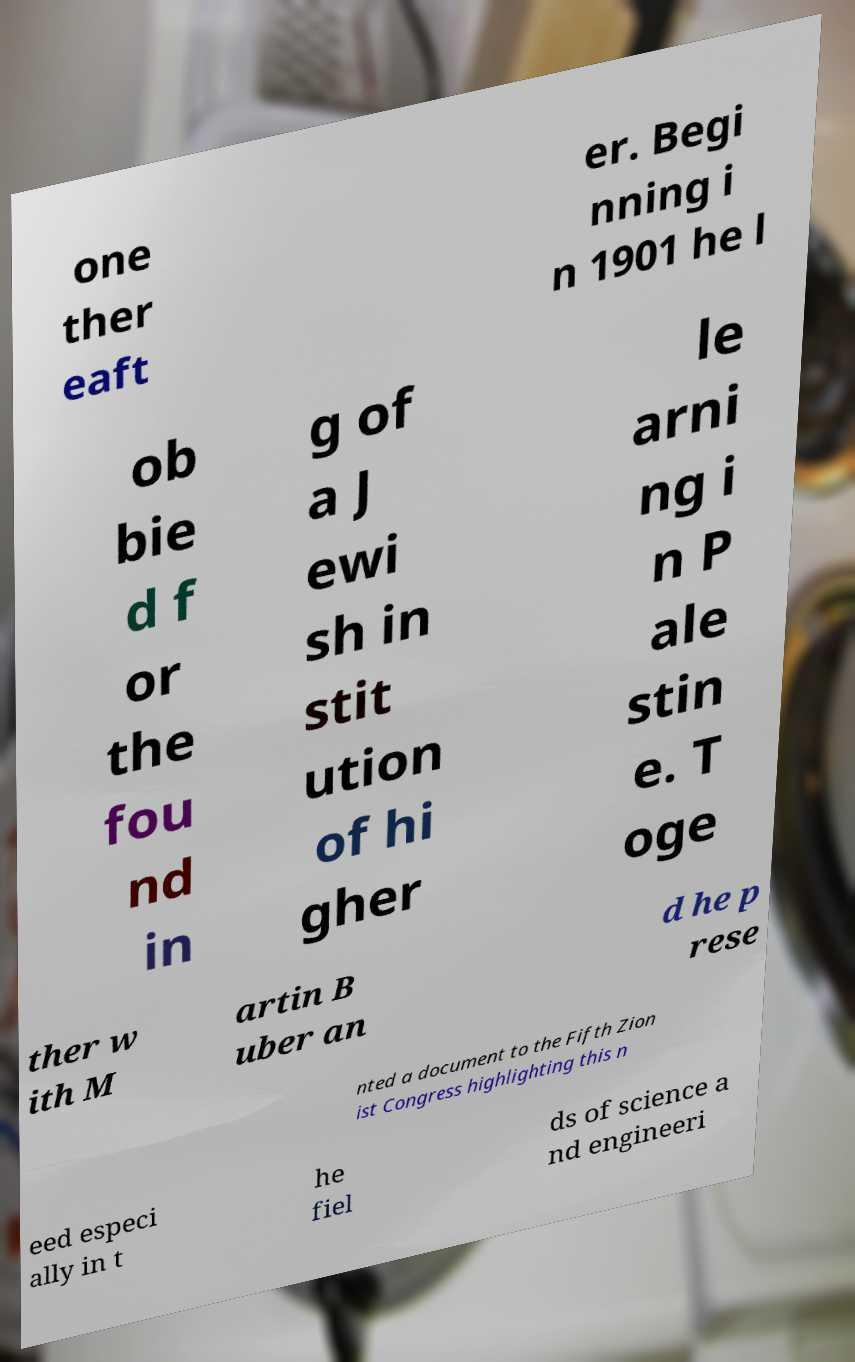Please read and relay the text visible in this image. What does it say? one ther eaft er. Begi nning i n 1901 he l ob bie d f or the fou nd in g of a J ewi sh in stit ution of hi gher le arni ng i n P ale stin e. T oge ther w ith M artin B uber an d he p rese nted a document to the Fifth Zion ist Congress highlighting this n eed especi ally in t he fiel ds of science a nd engineeri 